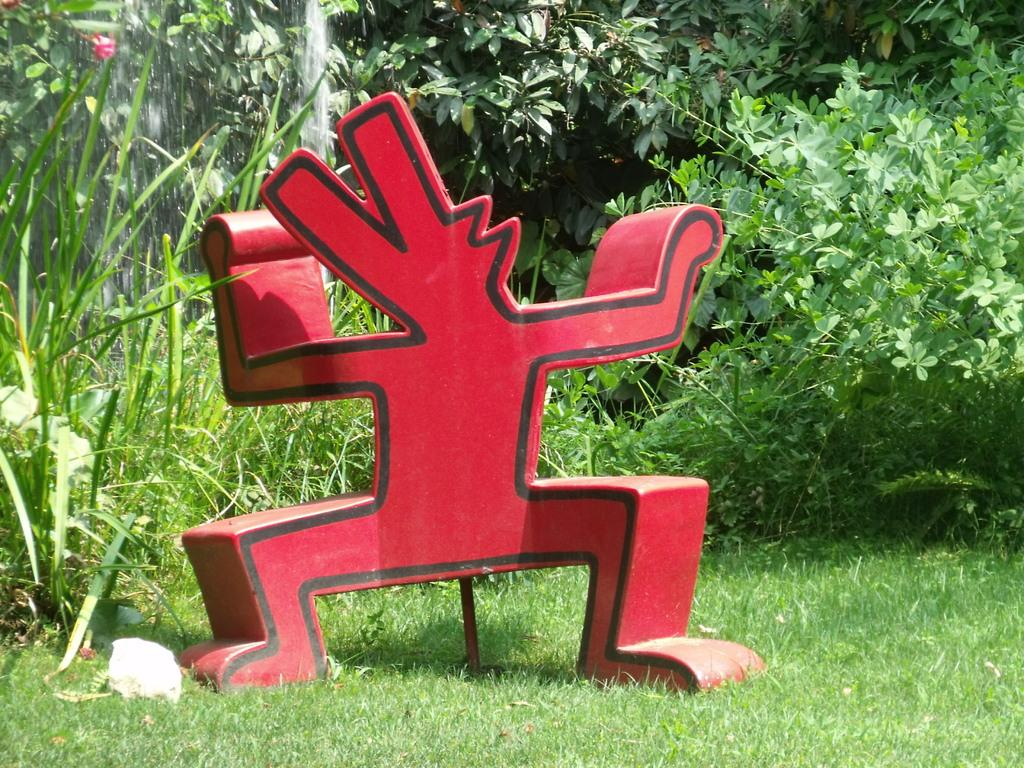What is the main object on the grass surface in the image? There is an object on a grass surface in the image, but the specific object is not mentioned in the facts. What type of vegetation can be seen in the image? There is a group of plants visible in the image. What else is visible in the image besides the grass and plants? There is water visible in the image. What is the opinion of the nerve about the house in the image? There is no house, opinion, or nerve present in the image. 